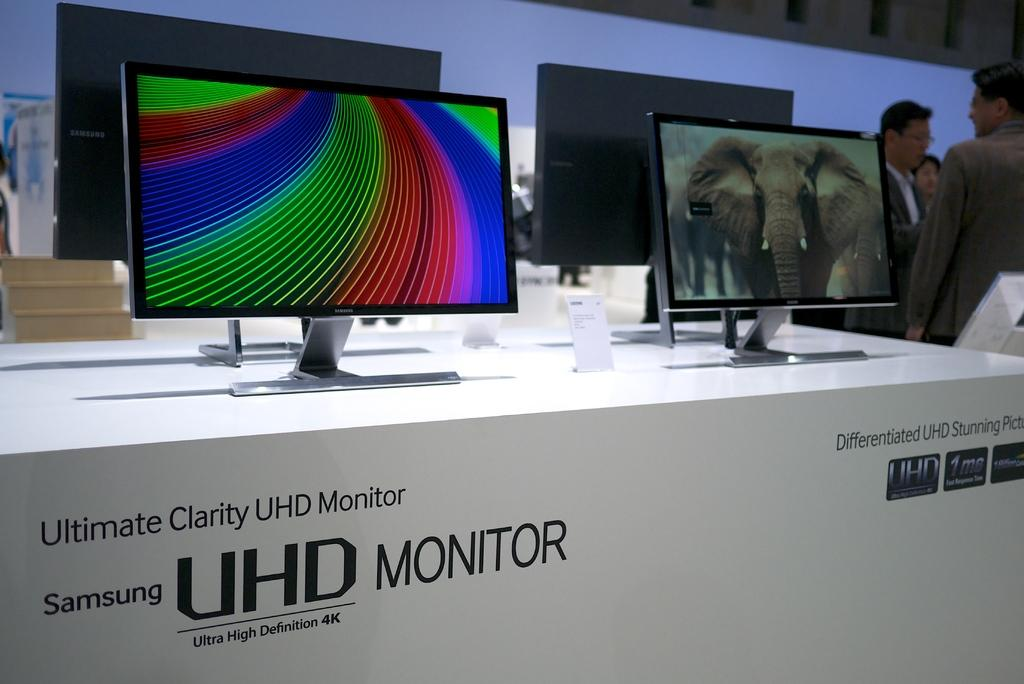<image>
Give a short and clear explanation of the subsequent image. Samsung HD monitors are displayed inside a store with different models displayed. 